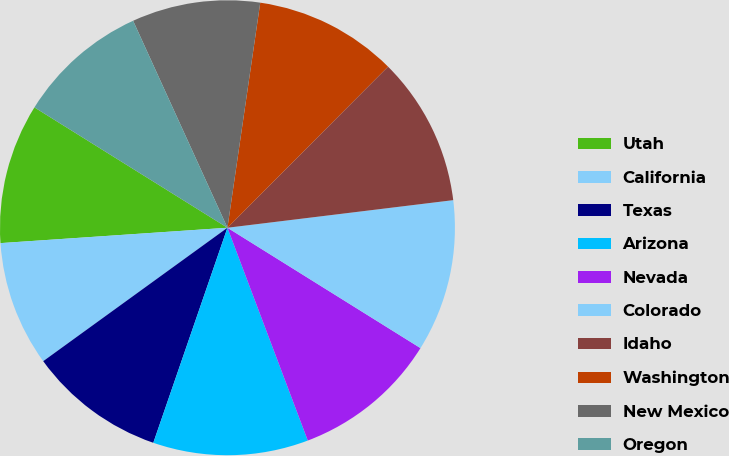Convert chart. <chart><loc_0><loc_0><loc_500><loc_500><pie_chart><fcel>Utah<fcel>California<fcel>Texas<fcel>Arizona<fcel>Nevada<fcel>Colorado<fcel>Idaho<fcel>Washington<fcel>New Mexico<fcel>Oregon<nl><fcel>9.95%<fcel>8.9%<fcel>9.74%<fcel>11.03%<fcel>10.38%<fcel>10.81%<fcel>10.59%<fcel>10.17%<fcel>9.11%<fcel>9.32%<nl></chart> 